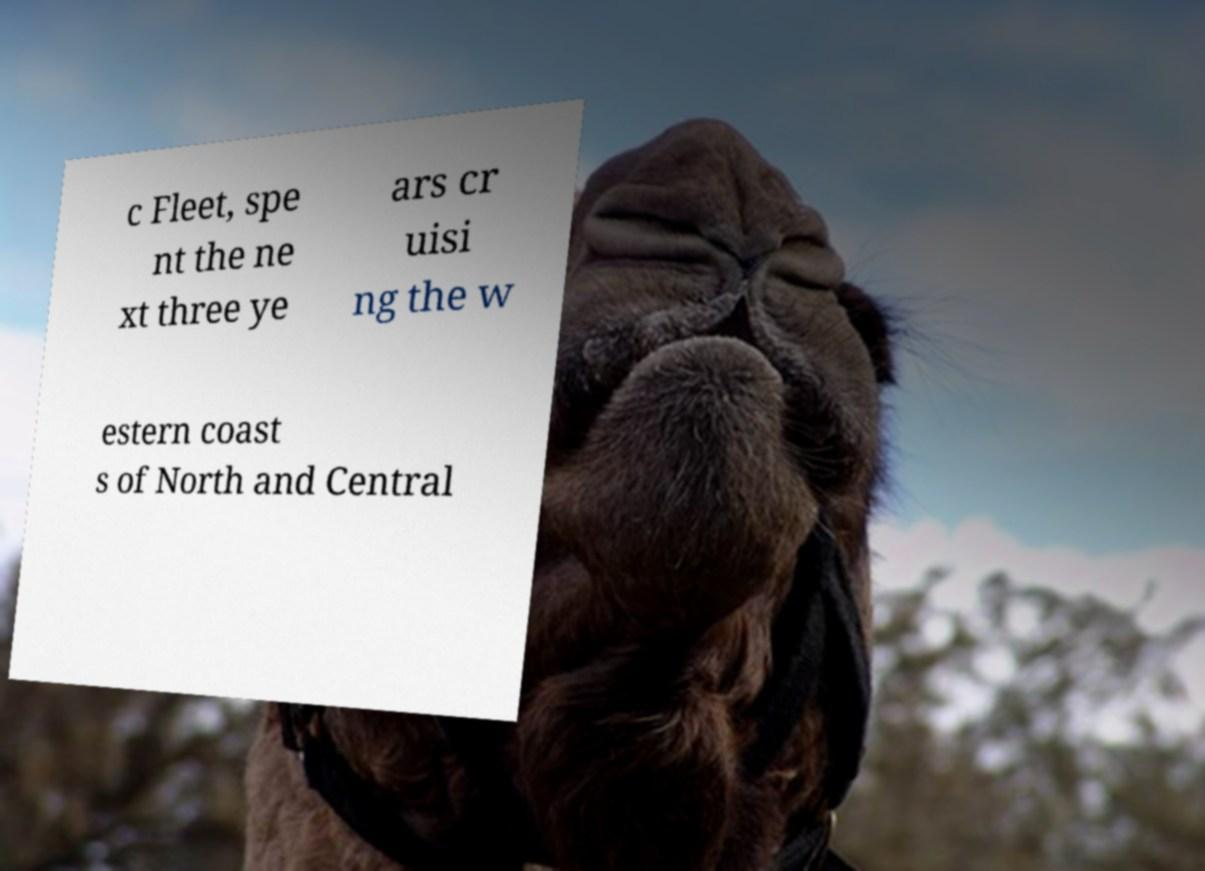Please read and relay the text visible in this image. What does it say? c Fleet, spe nt the ne xt three ye ars cr uisi ng the w estern coast s of North and Central 